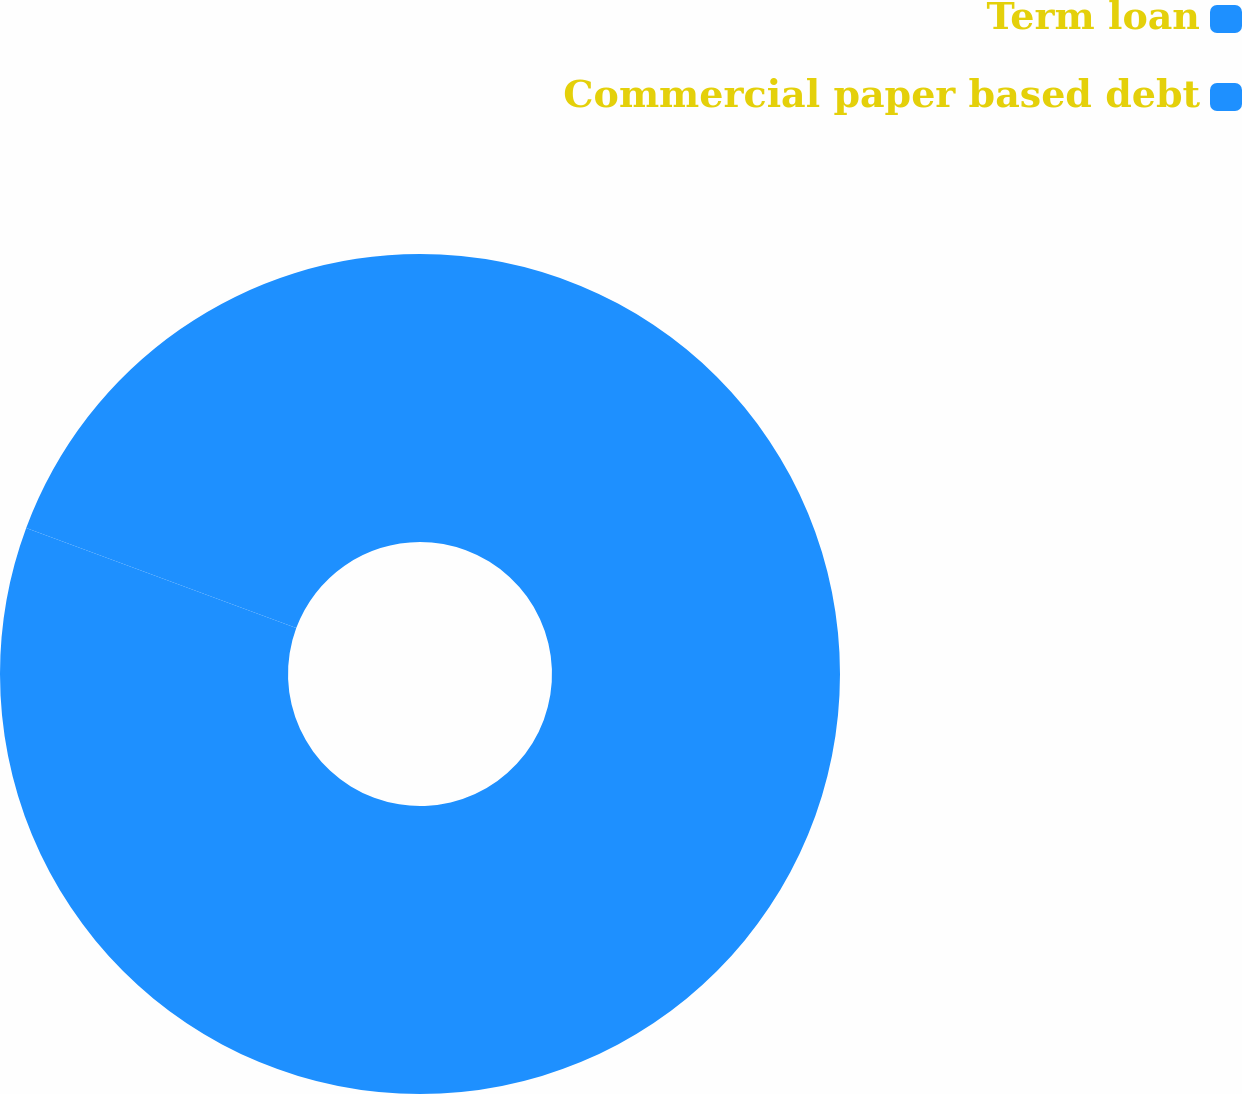Convert chart. <chart><loc_0><loc_0><loc_500><loc_500><pie_chart><fcel>Term loan<fcel>Commercial paper based debt<nl><fcel>80.65%<fcel>19.35%<nl></chart> 